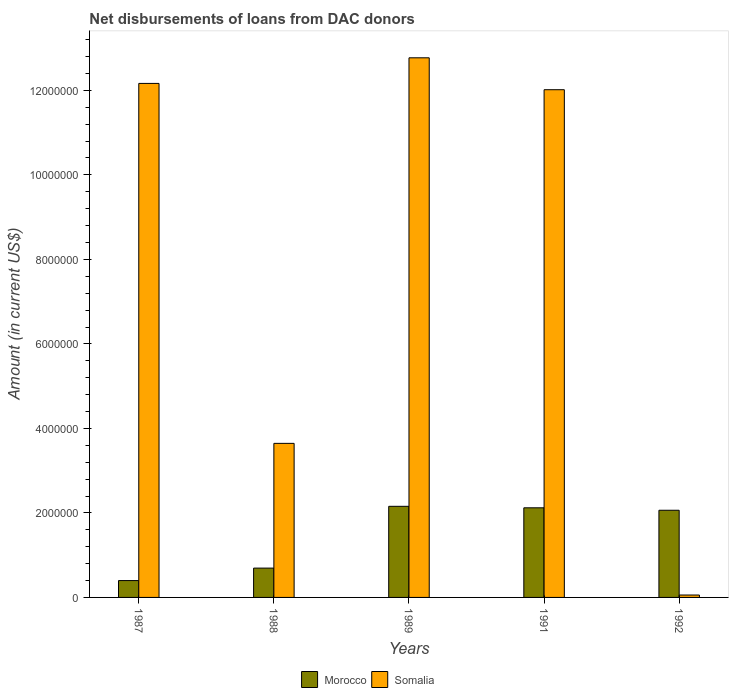How many different coloured bars are there?
Provide a succinct answer. 2. How many groups of bars are there?
Make the answer very short. 5. What is the label of the 5th group of bars from the left?
Your answer should be very brief. 1992. In how many cases, is the number of bars for a given year not equal to the number of legend labels?
Your answer should be compact. 0. What is the amount of loans disbursed in Somalia in 1989?
Offer a very short reply. 1.28e+07. Across all years, what is the maximum amount of loans disbursed in Morocco?
Your answer should be very brief. 2.16e+06. Across all years, what is the minimum amount of loans disbursed in Somalia?
Your answer should be very brief. 5.70e+04. In which year was the amount of loans disbursed in Somalia maximum?
Provide a short and direct response. 1989. What is the total amount of loans disbursed in Somalia in the graph?
Give a very brief answer. 4.07e+07. What is the difference between the amount of loans disbursed in Somalia in 1991 and that in 1992?
Your answer should be very brief. 1.20e+07. What is the difference between the amount of loans disbursed in Somalia in 1992 and the amount of loans disbursed in Morocco in 1991?
Provide a short and direct response. -2.06e+06. What is the average amount of loans disbursed in Somalia per year?
Provide a short and direct response. 8.13e+06. In the year 1987, what is the difference between the amount of loans disbursed in Morocco and amount of loans disbursed in Somalia?
Your answer should be very brief. -1.18e+07. In how many years, is the amount of loans disbursed in Somalia greater than 4000000 US$?
Offer a very short reply. 3. What is the ratio of the amount of loans disbursed in Somalia in 1989 to that in 1991?
Provide a succinct answer. 1.06. Is the difference between the amount of loans disbursed in Morocco in 1988 and 1989 greater than the difference between the amount of loans disbursed in Somalia in 1988 and 1989?
Give a very brief answer. Yes. What is the difference between the highest and the second highest amount of loans disbursed in Somalia?
Ensure brevity in your answer.  6.06e+05. What is the difference between the highest and the lowest amount of loans disbursed in Somalia?
Offer a terse response. 1.27e+07. In how many years, is the amount of loans disbursed in Morocco greater than the average amount of loans disbursed in Morocco taken over all years?
Ensure brevity in your answer.  3. Is the sum of the amount of loans disbursed in Morocco in 1987 and 1988 greater than the maximum amount of loans disbursed in Somalia across all years?
Your response must be concise. No. What does the 1st bar from the left in 1992 represents?
Offer a terse response. Morocco. What does the 1st bar from the right in 1988 represents?
Provide a short and direct response. Somalia. Are all the bars in the graph horizontal?
Give a very brief answer. No. Are the values on the major ticks of Y-axis written in scientific E-notation?
Make the answer very short. No. Does the graph contain grids?
Keep it short and to the point. No. Where does the legend appear in the graph?
Your answer should be very brief. Bottom center. How many legend labels are there?
Keep it short and to the point. 2. How are the legend labels stacked?
Offer a very short reply. Horizontal. What is the title of the graph?
Provide a short and direct response. Net disbursements of loans from DAC donors. What is the label or title of the X-axis?
Provide a succinct answer. Years. What is the label or title of the Y-axis?
Provide a short and direct response. Amount (in current US$). What is the Amount (in current US$) of Morocco in 1987?
Ensure brevity in your answer.  3.99e+05. What is the Amount (in current US$) in Somalia in 1987?
Your answer should be compact. 1.22e+07. What is the Amount (in current US$) in Morocco in 1988?
Provide a short and direct response. 6.94e+05. What is the Amount (in current US$) in Somalia in 1988?
Offer a terse response. 3.65e+06. What is the Amount (in current US$) in Morocco in 1989?
Your response must be concise. 2.16e+06. What is the Amount (in current US$) in Somalia in 1989?
Ensure brevity in your answer.  1.28e+07. What is the Amount (in current US$) of Morocco in 1991?
Offer a terse response. 2.12e+06. What is the Amount (in current US$) in Somalia in 1991?
Provide a short and direct response. 1.20e+07. What is the Amount (in current US$) of Morocco in 1992?
Provide a short and direct response. 2.06e+06. What is the Amount (in current US$) of Somalia in 1992?
Ensure brevity in your answer.  5.70e+04. Across all years, what is the maximum Amount (in current US$) in Morocco?
Keep it short and to the point. 2.16e+06. Across all years, what is the maximum Amount (in current US$) in Somalia?
Provide a succinct answer. 1.28e+07. Across all years, what is the minimum Amount (in current US$) in Morocco?
Your answer should be compact. 3.99e+05. Across all years, what is the minimum Amount (in current US$) of Somalia?
Provide a short and direct response. 5.70e+04. What is the total Amount (in current US$) of Morocco in the graph?
Your answer should be compact. 7.43e+06. What is the total Amount (in current US$) of Somalia in the graph?
Your response must be concise. 4.07e+07. What is the difference between the Amount (in current US$) of Morocco in 1987 and that in 1988?
Provide a succinct answer. -2.95e+05. What is the difference between the Amount (in current US$) in Somalia in 1987 and that in 1988?
Give a very brief answer. 8.52e+06. What is the difference between the Amount (in current US$) in Morocco in 1987 and that in 1989?
Your answer should be very brief. -1.76e+06. What is the difference between the Amount (in current US$) of Somalia in 1987 and that in 1989?
Ensure brevity in your answer.  -6.06e+05. What is the difference between the Amount (in current US$) in Morocco in 1987 and that in 1991?
Provide a succinct answer. -1.72e+06. What is the difference between the Amount (in current US$) of Somalia in 1987 and that in 1991?
Your response must be concise. 1.49e+05. What is the difference between the Amount (in current US$) in Morocco in 1987 and that in 1992?
Ensure brevity in your answer.  -1.66e+06. What is the difference between the Amount (in current US$) in Somalia in 1987 and that in 1992?
Give a very brief answer. 1.21e+07. What is the difference between the Amount (in current US$) in Morocco in 1988 and that in 1989?
Give a very brief answer. -1.46e+06. What is the difference between the Amount (in current US$) in Somalia in 1988 and that in 1989?
Keep it short and to the point. -9.12e+06. What is the difference between the Amount (in current US$) in Morocco in 1988 and that in 1991?
Provide a short and direct response. -1.43e+06. What is the difference between the Amount (in current US$) in Somalia in 1988 and that in 1991?
Make the answer very short. -8.37e+06. What is the difference between the Amount (in current US$) of Morocco in 1988 and that in 1992?
Make the answer very short. -1.37e+06. What is the difference between the Amount (in current US$) of Somalia in 1988 and that in 1992?
Offer a terse response. 3.59e+06. What is the difference between the Amount (in current US$) of Morocco in 1989 and that in 1991?
Make the answer very short. 3.50e+04. What is the difference between the Amount (in current US$) of Somalia in 1989 and that in 1991?
Offer a very short reply. 7.55e+05. What is the difference between the Amount (in current US$) in Morocco in 1989 and that in 1992?
Ensure brevity in your answer.  9.30e+04. What is the difference between the Amount (in current US$) in Somalia in 1989 and that in 1992?
Your answer should be very brief. 1.27e+07. What is the difference between the Amount (in current US$) of Morocco in 1991 and that in 1992?
Make the answer very short. 5.80e+04. What is the difference between the Amount (in current US$) of Somalia in 1991 and that in 1992?
Offer a very short reply. 1.20e+07. What is the difference between the Amount (in current US$) in Morocco in 1987 and the Amount (in current US$) in Somalia in 1988?
Provide a succinct answer. -3.25e+06. What is the difference between the Amount (in current US$) in Morocco in 1987 and the Amount (in current US$) in Somalia in 1989?
Ensure brevity in your answer.  -1.24e+07. What is the difference between the Amount (in current US$) in Morocco in 1987 and the Amount (in current US$) in Somalia in 1991?
Your answer should be compact. -1.16e+07. What is the difference between the Amount (in current US$) in Morocco in 1987 and the Amount (in current US$) in Somalia in 1992?
Give a very brief answer. 3.42e+05. What is the difference between the Amount (in current US$) of Morocco in 1988 and the Amount (in current US$) of Somalia in 1989?
Provide a short and direct response. -1.21e+07. What is the difference between the Amount (in current US$) of Morocco in 1988 and the Amount (in current US$) of Somalia in 1991?
Give a very brief answer. -1.13e+07. What is the difference between the Amount (in current US$) in Morocco in 1988 and the Amount (in current US$) in Somalia in 1992?
Your answer should be compact. 6.37e+05. What is the difference between the Amount (in current US$) in Morocco in 1989 and the Amount (in current US$) in Somalia in 1991?
Give a very brief answer. -9.86e+06. What is the difference between the Amount (in current US$) in Morocco in 1989 and the Amount (in current US$) in Somalia in 1992?
Your answer should be compact. 2.10e+06. What is the difference between the Amount (in current US$) of Morocco in 1991 and the Amount (in current US$) of Somalia in 1992?
Offer a very short reply. 2.06e+06. What is the average Amount (in current US$) of Morocco per year?
Make the answer very short. 1.49e+06. What is the average Amount (in current US$) in Somalia per year?
Ensure brevity in your answer.  8.13e+06. In the year 1987, what is the difference between the Amount (in current US$) in Morocco and Amount (in current US$) in Somalia?
Make the answer very short. -1.18e+07. In the year 1988, what is the difference between the Amount (in current US$) of Morocco and Amount (in current US$) of Somalia?
Your response must be concise. -2.95e+06. In the year 1989, what is the difference between the Amount (in current US$) of Morocco and Amount (in current US$) of Somalia?
Offer a very short reply. -1.06e+07. In the year 1991, what is the difference between the Amount (in current US$) in Morocco and Amount (in current US$) in Somalia?
Provide a succinct answer. -9.90e+06. In the year 1992, what is the difference between the Amount (in current US$) in Morocco and Amount (in current US$) in Somalia?
Your response must be concise. 2.01e+06. What is the ratio of the Amount (in current US$) in Morocco in 1987 to that in 1988?
Make the answer very short. 0.57. What is the ratio of the Amount (in current US$) of Somalia in 1987 to that in 1988?
Make the answer very short. 3.34. What is the ratio of the Amount (in current US$) of Morocco in 1987 to that in 1989?
Provide a short and direct response. 0.19. What is the ratio of the Amount (in current US$) in Somalia in 1987 to that in 1989?
Your answer should be very brief. 0.95. What is the ratio of the Amount (in current US$) of Morocco in 1987 to that in 1991?
Provide a succinct answer. 0.19. What is the ratio of the Amount (in current US$) in Somalia in 1987 to that in 1991?
Keep it short and to the point. 1.01. What is the ratio of the Amount (in current US$) of Morocco in 1987 to that in 1992?
Make the answer very short. 0.19. What is the ratio of the Amount (in current US$) of Somalia in 1987 to that in 1992?
Make the answer very short. 213.42. What is the ratio of the Amount (in current US$) in Morocco in 1988 to that in 1989?
Make the answer very short. 0.32. What is the ratio of the Amount (in current US$) of Somalia in 1988 to that in 1989?
Make the answer very short. 0.29. What is the ratio of the Amount (in current US$) of Morocco in 1988 to that in 1991?
Your answer should be very brief. 0.33. What is the ratio of the Amount (in current US$) of Somalia in 1988 to that in 1991?
Provide a succinct answer. 0.3. What is the ratio of the Amount (in current US$) in Morocco in 1988 to that in 1992?
Your answer should be compact. 0.34. What is the ratio of the Amount (in current US$) of Somalia in 1988 to that in 1992?
Offer a terse response. 63.96. What is the ratio of the Amount (in current US$) of Morocco in 1989 to that in 1991?
Your answer should be very brief. 1.02. What is the ratio of the Amount (in current US$) of Somalia in 1989 to that in 1991?
Ensure brevity in your answer.  1.06. What is the ratio of the Amount (in current US$) in Morocco in 1989 to that in 1992?
Provide a short and direct response. 1.05. What is the ratio of the Amount (in current US$) of Somalia in 1989 to that in 1992?
Give a very brief answer. 224.05. What is the ratio of the Amount (in current US$) of Morocco in 1991 to that in 1992?
Your response must be concise. 1.03. What is the ratio of the Amount (in current US$) of Somalia in 1991 to that in 1992?
Make the answer very short. 210.81. What is the difference between the highest and the second highest Amount (in current US$) of Morocco?
Make the answer very short. 3.50e+04. What is the difference between the highest and the second highest Amount (in current US$) of Somalia?
Keep it short and to the point. 6.06e+05. What is the difference between the highest and the lowest Amount (in current US$) of Morocco?
Provide a short and direct response. 1.76e+06. What is the difference between the highest and the lowest Amount (in current US$) in Somalia?
Provide a short and direct response. 1.27e+07. 